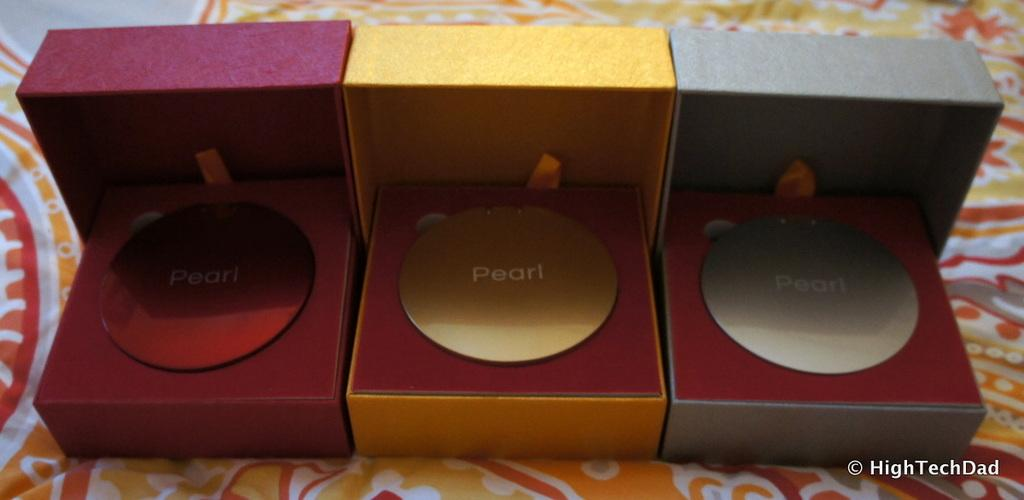<image>
Present a compact description of the photo's key features. Three boxes with a pearl wrote in the inside 